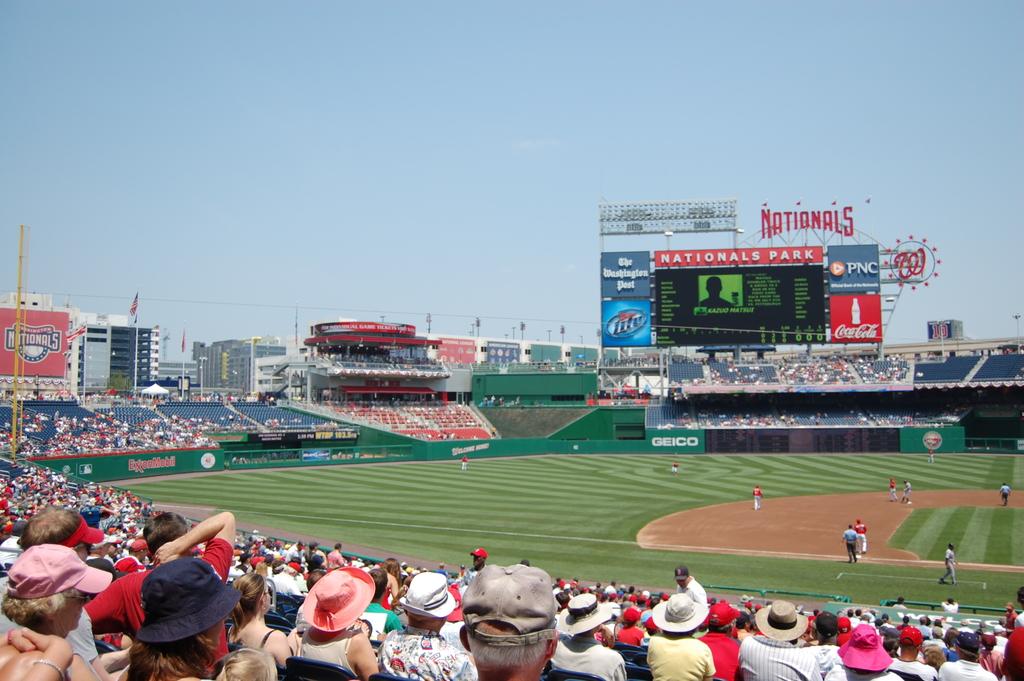What is the brand of the drink advertised in the board?
Keep it short and to the point. Coca cola. What national baseball park is this game taking place?
Ensure brevity in your answer.  Nationals park. 